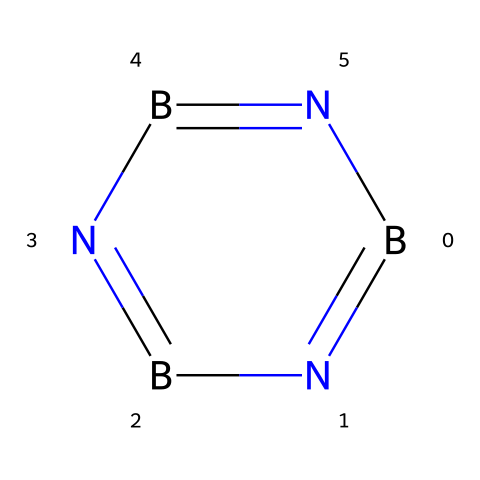What is the molecular formula of this compound? The SMILES representation shows one boron (B) and three nitrogen (N) atoms connected in a cyclic structure. The molecular formula is derived from counting the unique atoms present.
Answer: B3N3 How many bonds are present between the boron and nitrogen atoms? The SMILES indicates alternating bonds between the boron and nitrogen atoms. Each bond type can be visualized as single or double based on the "=" sign and their connectivity implies connectivity between pairs of these atoms. In this structure, there are three alternating double bonds forming a ring.
Answer: 3 Is this compound cyclic or acyclic? The presence of '1' in the SMILES indicates that the structure closes back on itself, forming a loop or cycle. A cyclic structure means that the atoms are arranged in a ring rather than a straight chain.
Answer: cyclic What type of bonding is observed in this compound? The "=" signs in the SMILES notation represent double bonds. A deeper analysis reveals that the alternating bonds between boron and nitrogen indicate resonance character, common in nitrogen-rich compounds.
Answer: double bonds What is the geometry around the boron atoms in this structure? Considering the hybridization and number of surrounding atoms, the geometry around each boron atom in a trigonal planar arrangement can be inferred from the three bonds formed with vacant orbitals allowing for double bonds. This arrangement affects the overall molecular geometry of the compound.
Answer: trigonal planar What unique properties might this boron compound exhibit compared to carbon structures? The presence of boron and nitrogen instead of carbon suggests potential differences in properties like electron deficiency, different melting points, and possibly higher thermal stability. Characterizing these differences requires knowledge of typical borane chemistry, which often includes unique reaction behavior.
Answer: electron deficiency 